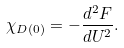Convert formula to latex. <formula><loc_0><loc_0><loc_500><loc_500>\chi _ { D ( 0 ) } = - \frac { d ^ { 2 } F } { d U ^ { 2 } } .</formula> 